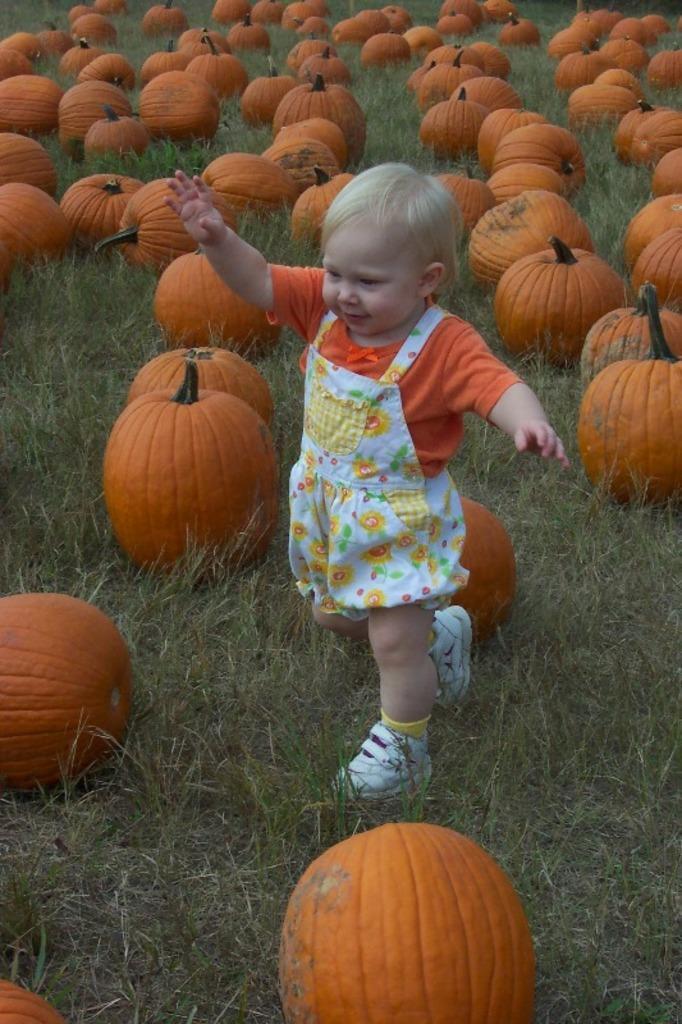Describe this image in one or two sentences. There is a girl walking and we can see pumpkins on the grass. 